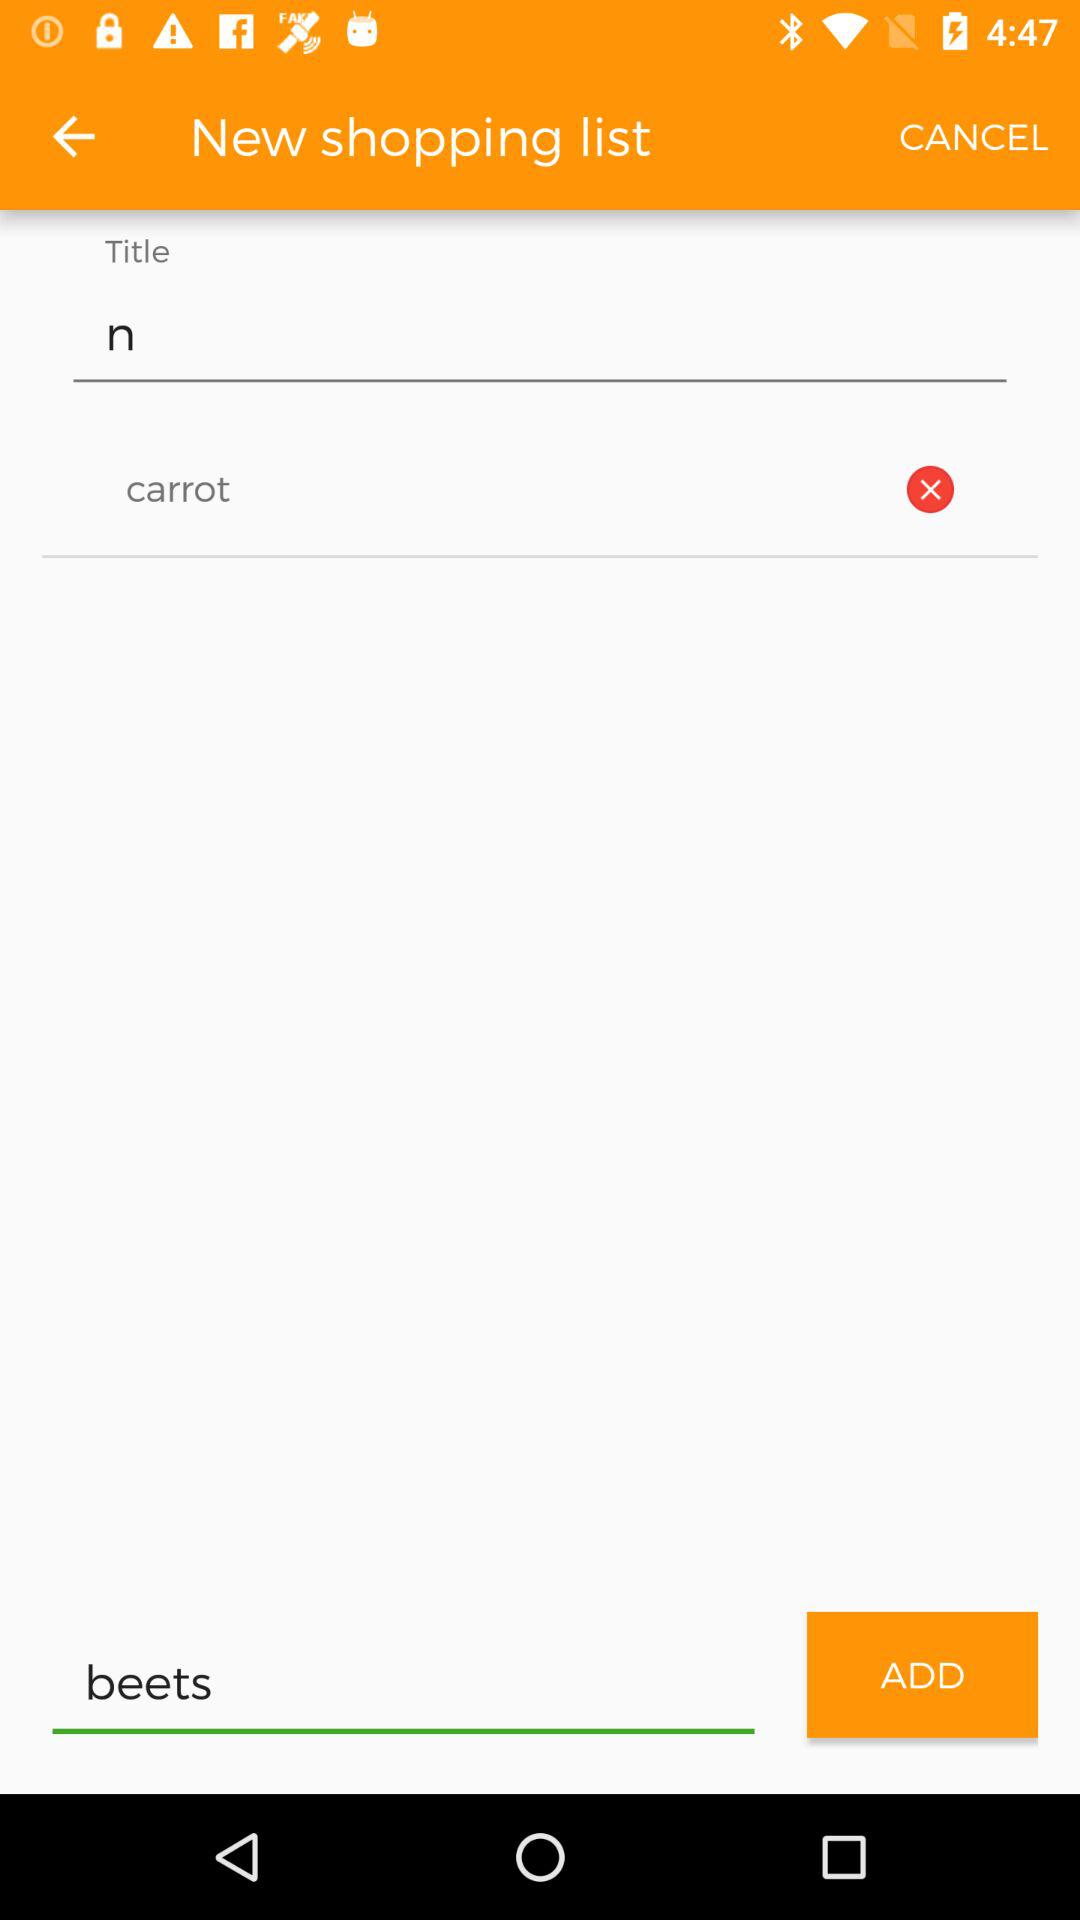What is the title? The title is "n". 